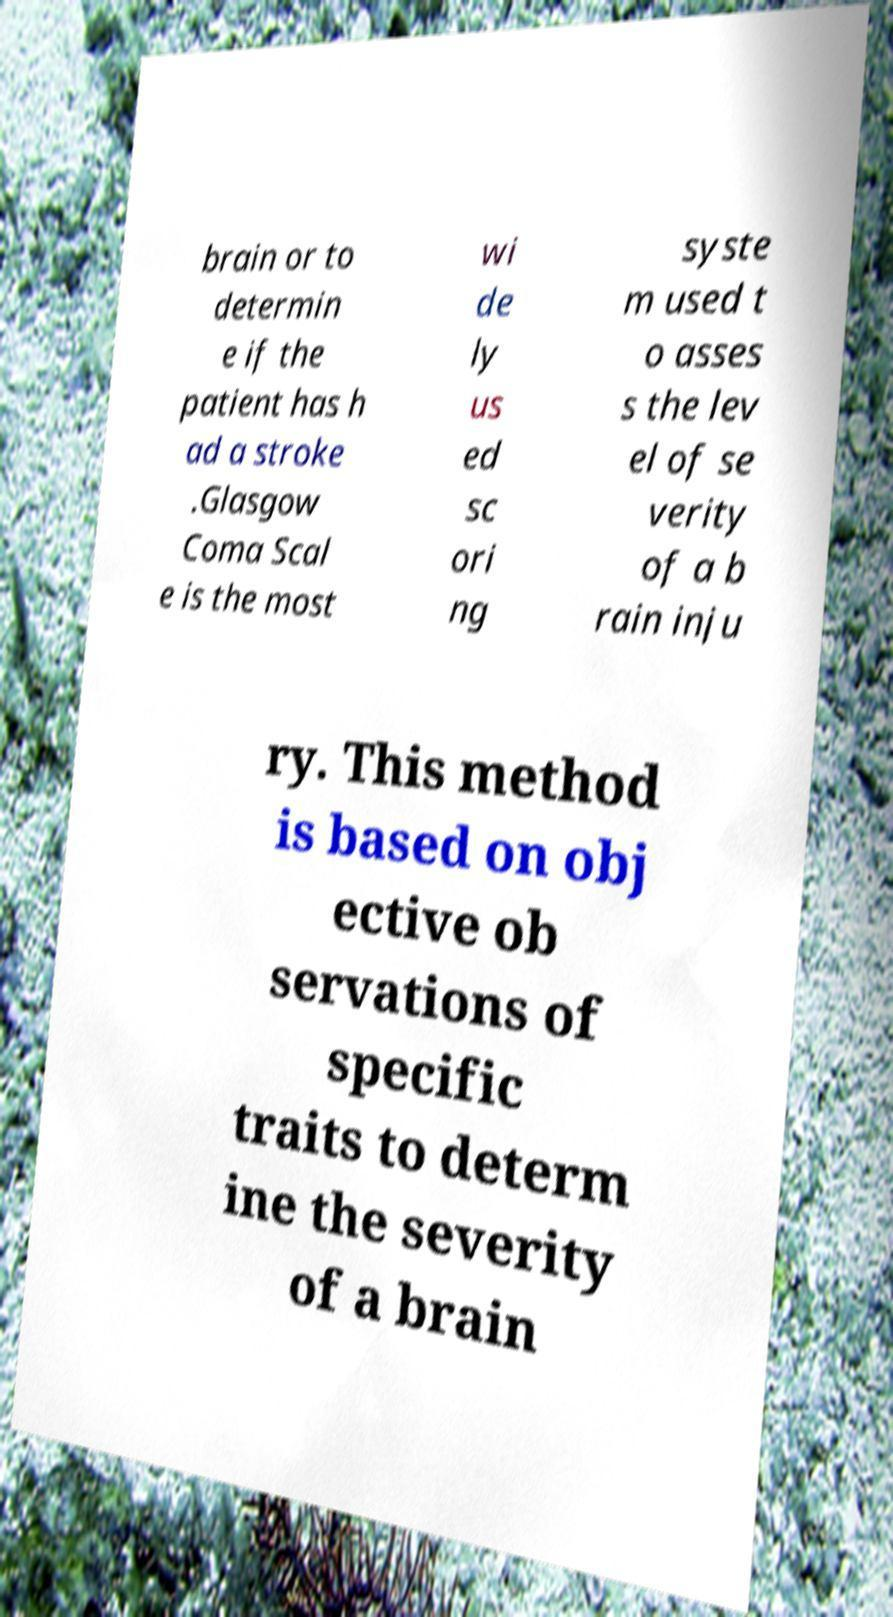Could you assist in decoding the text presented in this image and type it out clearly? brain or to determin e if the patient has h ad a stroke .Glasgow Coma Scal e is the most wi de ly us ed sc ori ng syste m used t o asses s the lev el of se verity of a b rain inju ry. This method is based on obj ective ob servations of specific traits to determ ine the severity of a brain 